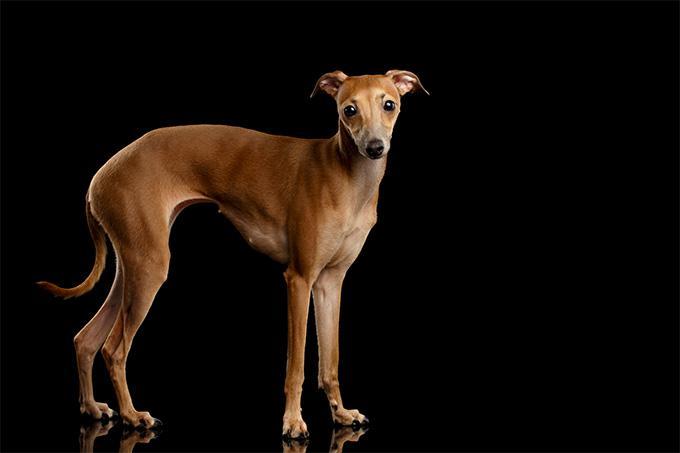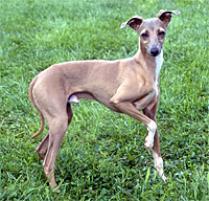The first image is the image on the left, the second image is the image on the right. Considering the images on both sides, is "The right image shows a dog with all four paws on green grass." valid? Answer yes or no. No. 